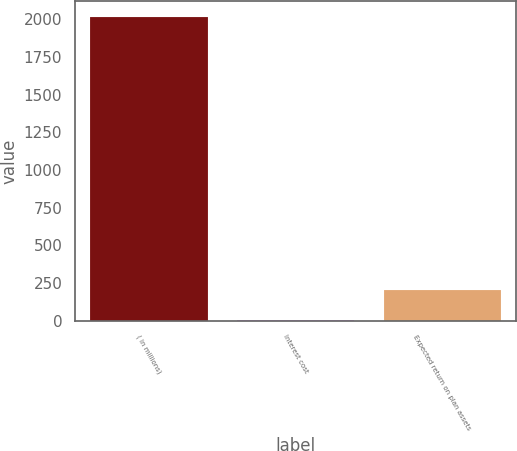Convert chart to OTSL. <chart><loc_0><loc_0><loc_500><loc_500><bar_chart><fcel>( in millions)<fcel>Interest cost<fcel>Expected return on plan assets<nl><fcel>2018<fcel>1.2<fcel>202.88<nl></chart> 